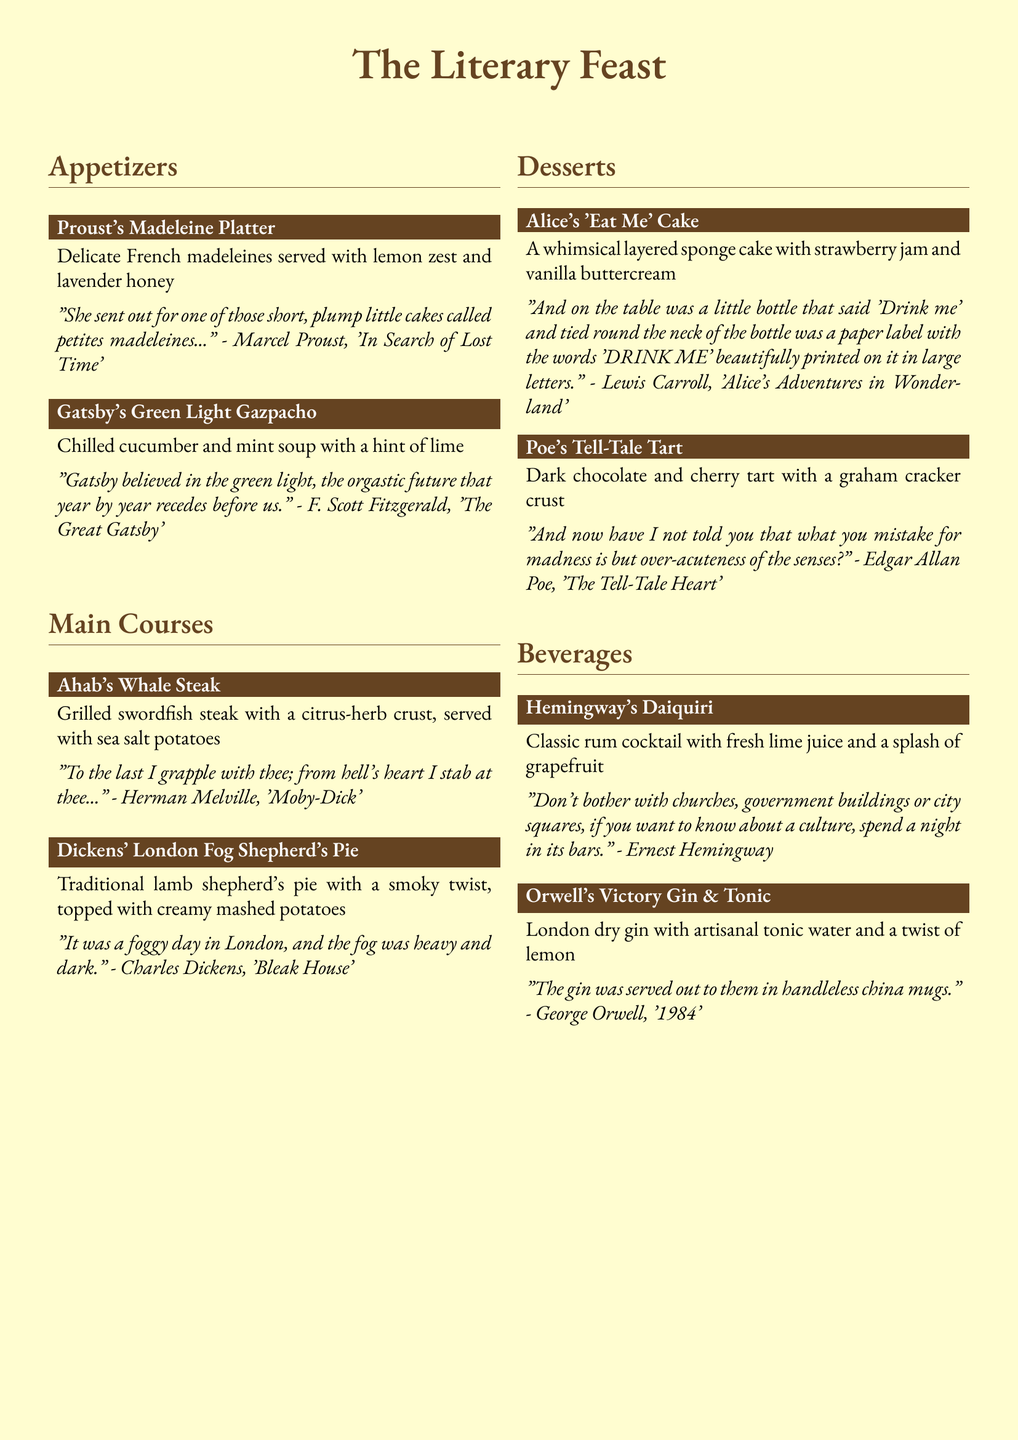What is the name of the appetizer inspired by Proust? The appetizer inspired by Proust is "Proust's Madeleine Platter."
Answer: Proust's Madeleine Platter What type of soup is offered in Gatsby's dish? Gatsby's dish features a "chilled cucumber and mint soup."
Answer: chilled cucumber and mint soup Which main course features a steak? The main course that features a steak is "Ahab's Whale Steak."
Answer: Ahab's Whale Steak What is the main ingredient in Dickens' shepherd's pie? The main ingredient in Dickens' shepherd's pie is "lamb."
Answer: lamb Which author is associated with dessert through the quote about "Drink me"? The author associated with this dessert quote is "Lewis Carroll."
Answer: Lewis Carroll What kind of beverage is Hemingway's featured drink? Hemingway's drink is a "classic rum cocktail."
Answer: classic rum cocktail What type of tart is Poe's dessert? Poe's dessert is a "dark chocolate and cherry tart."
Answer: dark chocolate and cherry tart How many sections are there in the menu? The menu contains "three sections."
Answer: three sections What is the common theme of the menu items? The common theme is "literature."
Answer: literature 